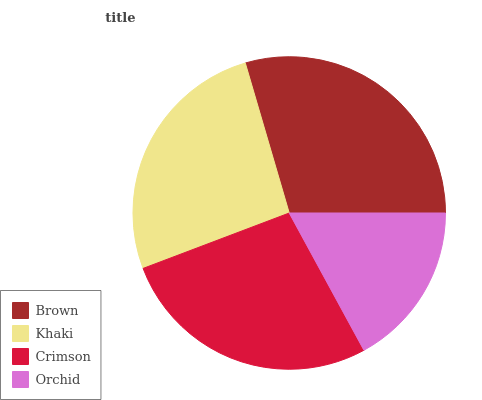Is Orchid the minimum?
Answer yes or no. Yes. Is Brown the maximum?
Answer yes or no. Yes. Is Khaki the minimum?
Answer yes or no. No. Is Khaki the maximum?
Answer yes or no. No. Is Brown greater than Khaki?
Answer yes or no. Yes. Is Khaki less than Brown?
Answer yes or no. Yes. Is Khaki greater than Brown?
Answer yes or no. No. Is Brown less than Khaki?
Answer yes or no. No. Is Crimson the high median?
Answer yes or no. Yes. Is Khaki the low median?
Answer yes or no. Yes. Is Orchid the high median?
Answer yes or no. No. Is Brown the low median?
Answer yes or no. No. 